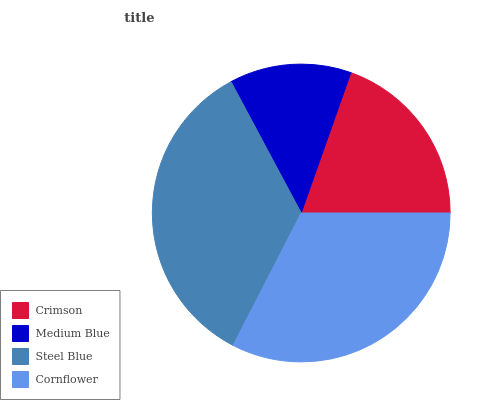Is Medium Blue the minimum?
Answer yes or no. Yes. Is Steel Blue the maximum?
Answer yes or no. Yes. Is Steel Blue the minimum?
Answer yes or no. No. Is Medium Blue the maximum?
Answer yes or no. No. Is Steel Blue greater than Medium Blue?
Answer yes or no. Yes. Is Medium Blue less than Steel Blue?
Answer yes or no. Yes. Is Medium Blue greater than Steel Blue?
Answer yes or no. No. Is Steel Blue less than Medium Blue?
Answer yes or no. No. Is Cornflower the high median?
Answer yes or no. Yes. Is Crimson the low median?
Answer yes or no. Yes. Is Crimson the high median?
Answer yes or no. No. Is Steel Blue the low median?
Answer yes or no. No. 